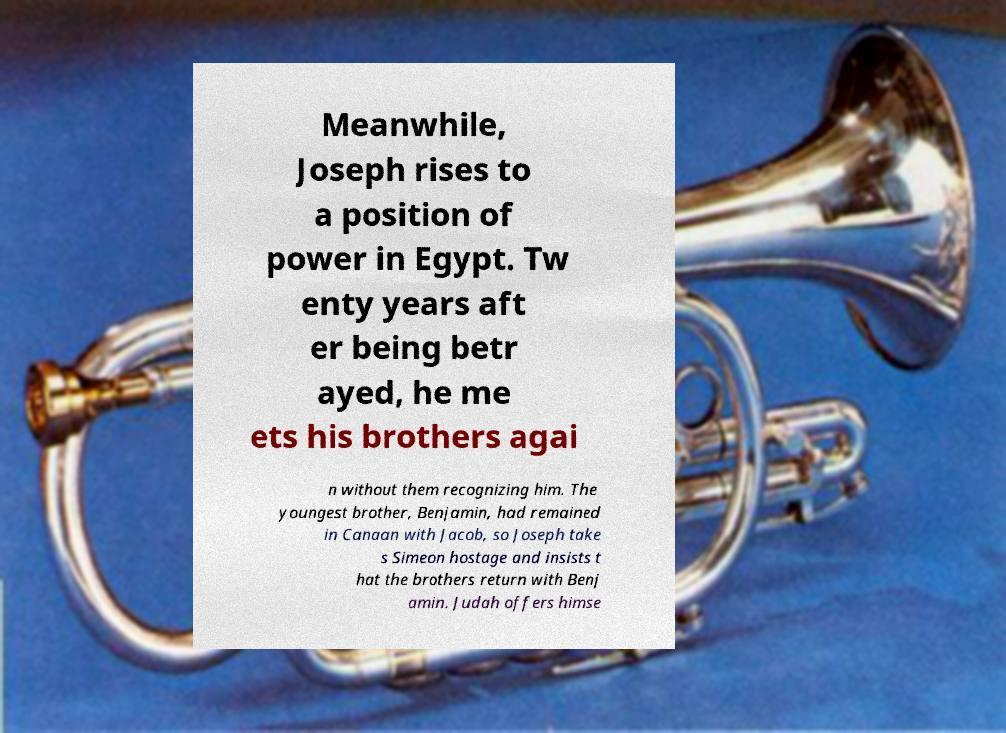Please identify and transcribe the text found in this image. Meanwhile, Joseph rises to a position of power in Egypt. Tw enty years aft er being betr ayed, he me ets his brothers agai n without them recognizing him. The youngest brother, Benjamin, had remained in Canaan with Jacob, so Joseph take s Simeon hostage and insists t hat the brothers return with Benj amin. Judah offers himse 